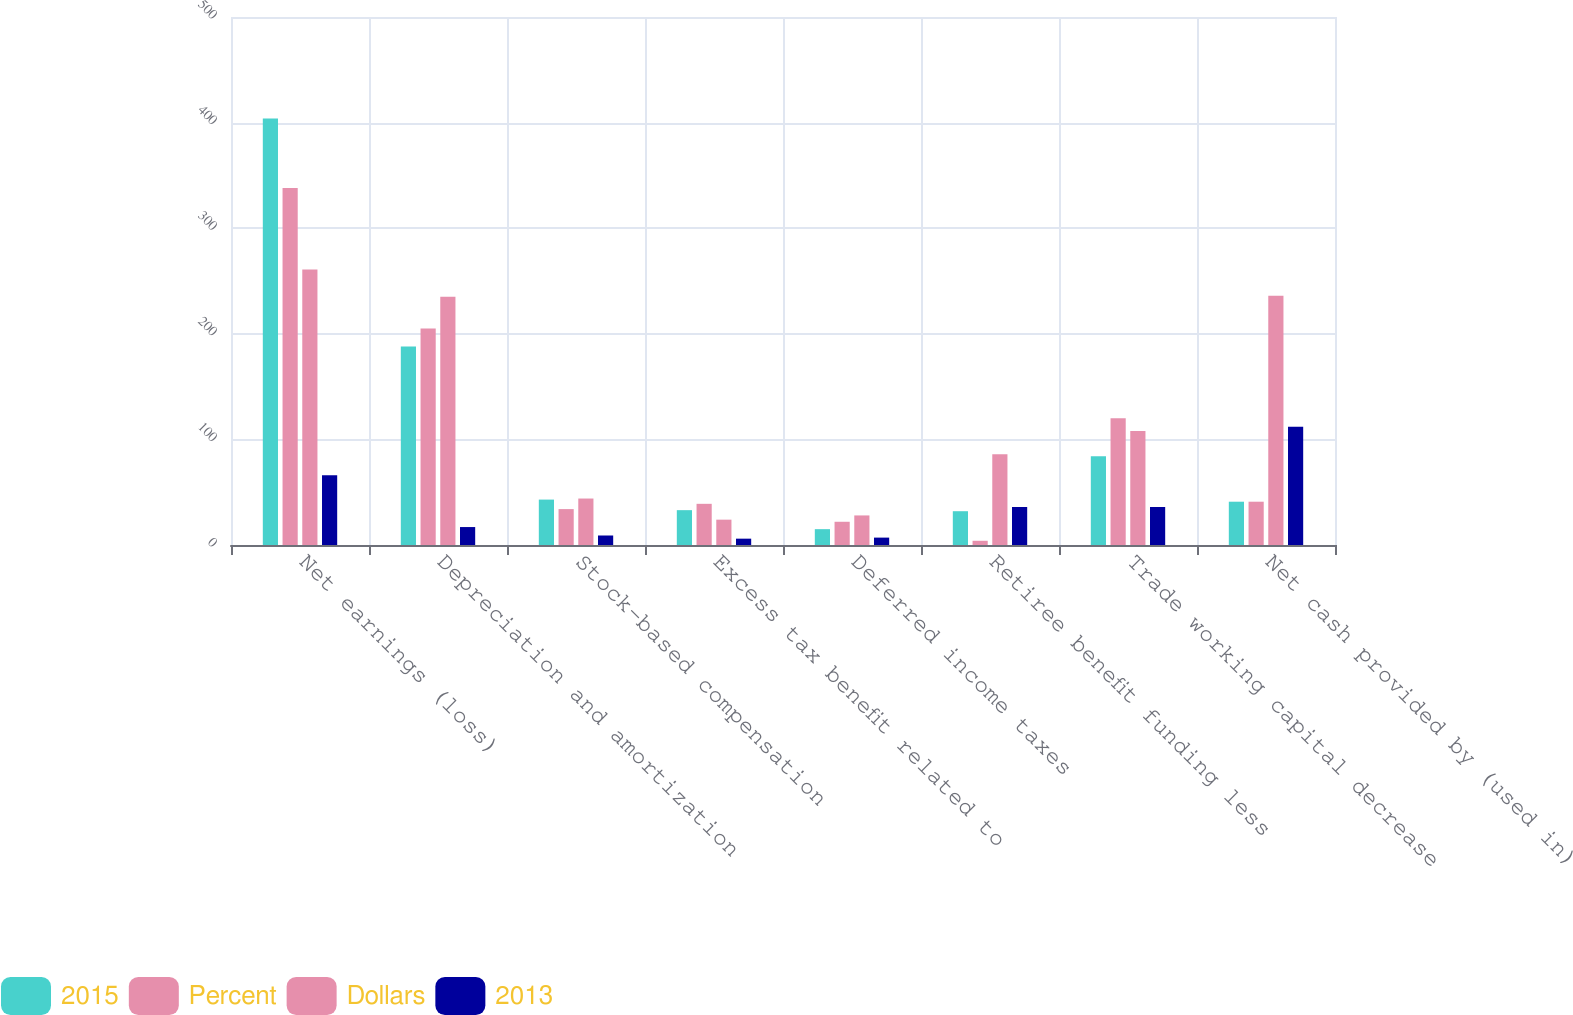Convert chart. <chart><loc_0><loc_0><loc_500><loc_500><stacked_bar_chart><ecel><fcel>Net earnings (loss)<fcel>Depreciation and amortization<fcel>Stock-based compensation<fcel>Excess tax benefit related to<fcel>Deferred income taxes<fcel>Retiree benefit funding less<fcel>Trade working capital decrease<fcel>Net cash provided by (used in)<nl><fcel>2015<fcel>404<fcel>188<fcel>43<fcel>33<fcel>15<fcel>32<fcel>84<fcel>41<nl><fcel>Percent<fcel>338<fcel>205<fcel>34<fcel>39<fcel>22<fcel>4<fcel>120<fcel>41<nl><fcel>Dollars<fcel>261<fcel>235<fcel>44<fcel>24<fcel>28<fcel>86<fcel>108<fcel>236<nl><fcel>2013<fcel>66<fcel>17<fcel>9<fcel>6<fcel>7<fcel>36<fcel>36<fcel>112<nl></chart> 